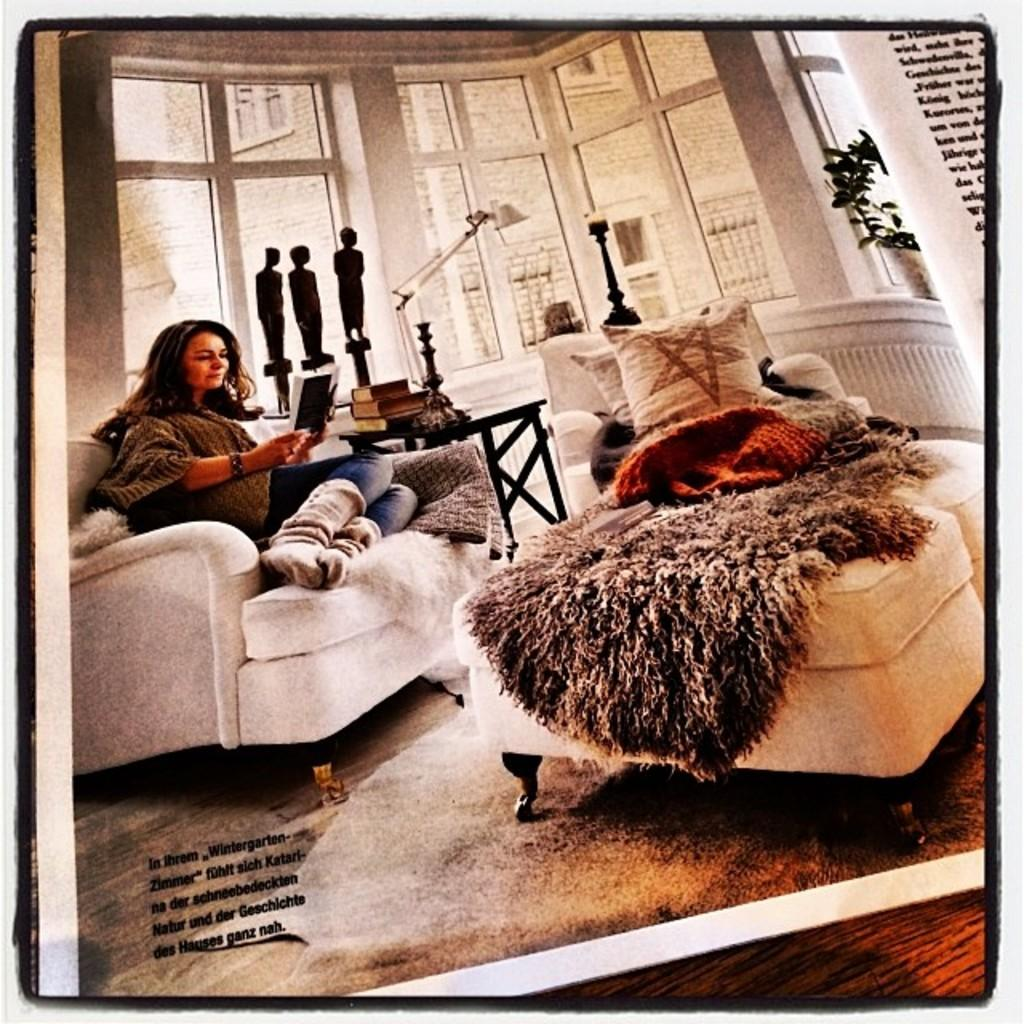Who is present in the image? There is a woman in the image. What is the woman doing in the image? The woman is seated on a chair and holding a book in her hand. What other objects can be seen in the image? There is a stool with pillows on it and a plant in the image. What type of crown is the woman wearing in the image? There is no crown present in the image; the woman is simply holding a book. 